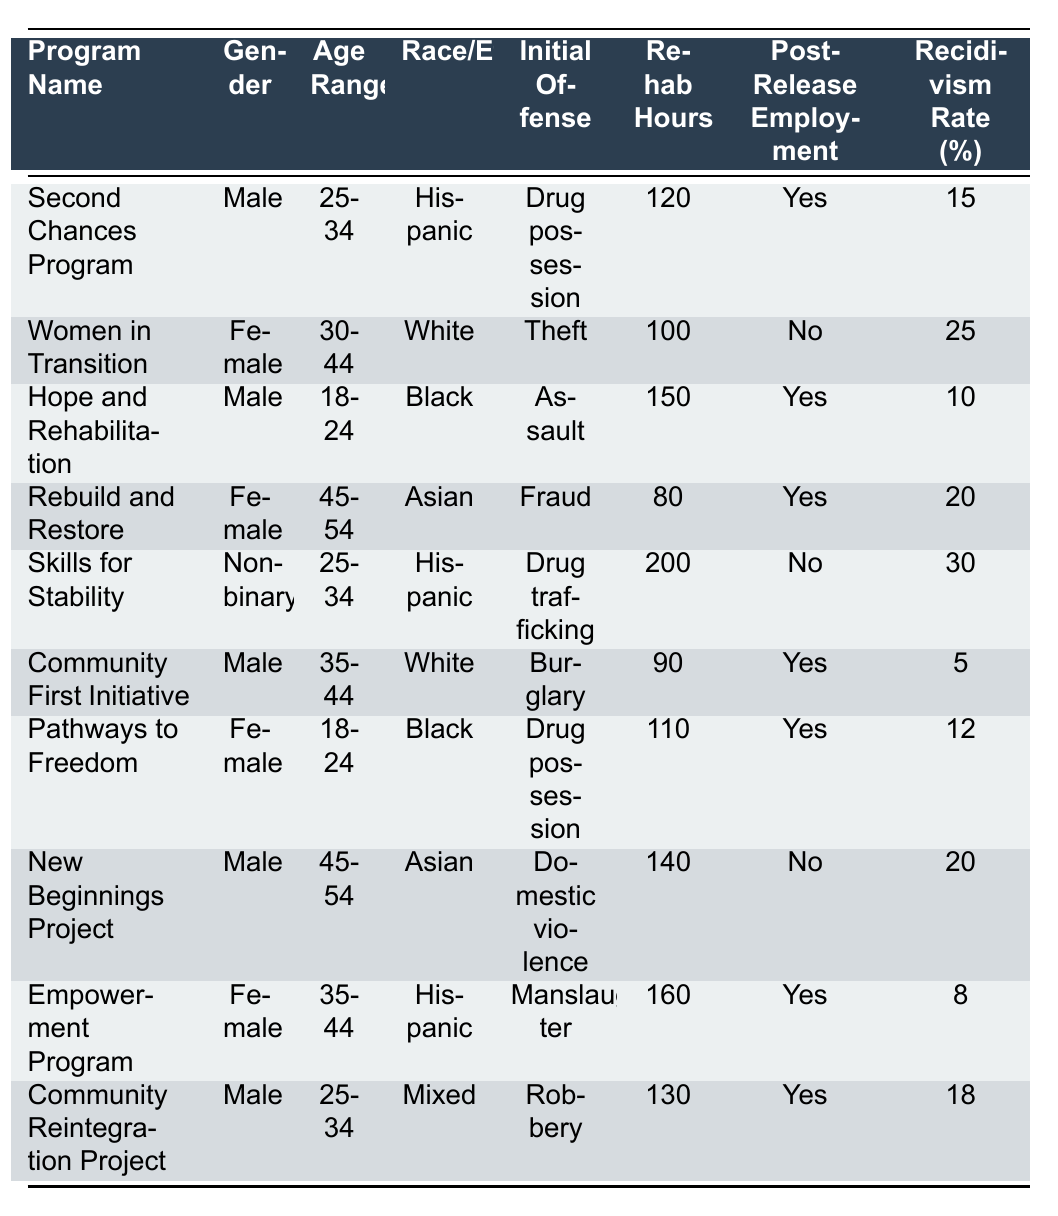What is the recidivism rate for the Community First Initiative? The table lists the recidivism rate for the Community First Initiative as 5%.
Answer: 5% Which program has the highest recidivism rate? By comparing the recidivism rates in the table, the Skills for Stability program has the highest rate at 30%.
Answer: Skills for Stability How many rehabilitation hours were provided in total for the programs that have post-release employment? The programs with post-release employment are: Second Chances Program (120 hours), Hope and Rehabilitation (150 hours), Rebuild and Restore (80 hours), Community First Initiative (90 hours), Pathways to Freedom (110 hours), Empowerment Program (160 hours), and Community Reintegration Project (130 hours). The sum of these hours is 120 + 150 + 80 + 90 + 110 + 160 + 130 = 840 hours.
Answer: 840 hours Is the initial offense of the Hope and Rehabilitation program related to drug possession? The initial offense listed for the Hope and Rehabilitation program is Assault, not Drug possession. Therefore, the statement is false.
Answer: No What is the average recidivism rate among all programs for females? The recidivism rates for female programs are: Women in Transition (25%), Rebuild and Restore (20%), Pathways to Freedom (12%), and Empowerment Program (8%). The average is calculated as (25 + 20 + 12 + 8) / 4 = 65 / 4 = 16.25%.
Answer: 16.25% What is the difference in rehabilitation hours between the program with the lowest recidivism rate and the one with the highest? The program with the lowest recidivism rate is Community First Initiative with 90 hours, and the program with the highest is Skills for Stability with 200 hours. The difference is 200 - 90 = 110 hours.
Answer: 110 hours Which race/ethnicity has the highest representation in the programs listed? By counting the entries, Hispanic appears 3 times (Second Chances, Skills for Stability, Empowerment Program), White appears 3 times (Women in Transition, Community First Initiative, and one other program), Black appears 2 times (Hope and Rehabilitation, Pathways to Freedom), and Asian appears 2 times (Rebuild and Restore, New Beginnings Project). Mixed and Non-binary appear once each. Therefore, there is a tie between Hispanic and White.
Answer: Hispanic and White (tie) Did any program have a recidivism rate of 12% or less? Yes, the Hope and Rehabilitation program (10%) and the Empowerment Program (8%) both have rates of 12% or less.
Answer: Yes Which age range has the fewest records in this table? The age range 45-54 has three entries (Rebuild and Restore, New Beginnings Project) while others like 25-34, and 18-24 have more. However, the 30-44 age range has two entries. Hence, the age range 30-44 has the fewest records.
Answer: 30-44 